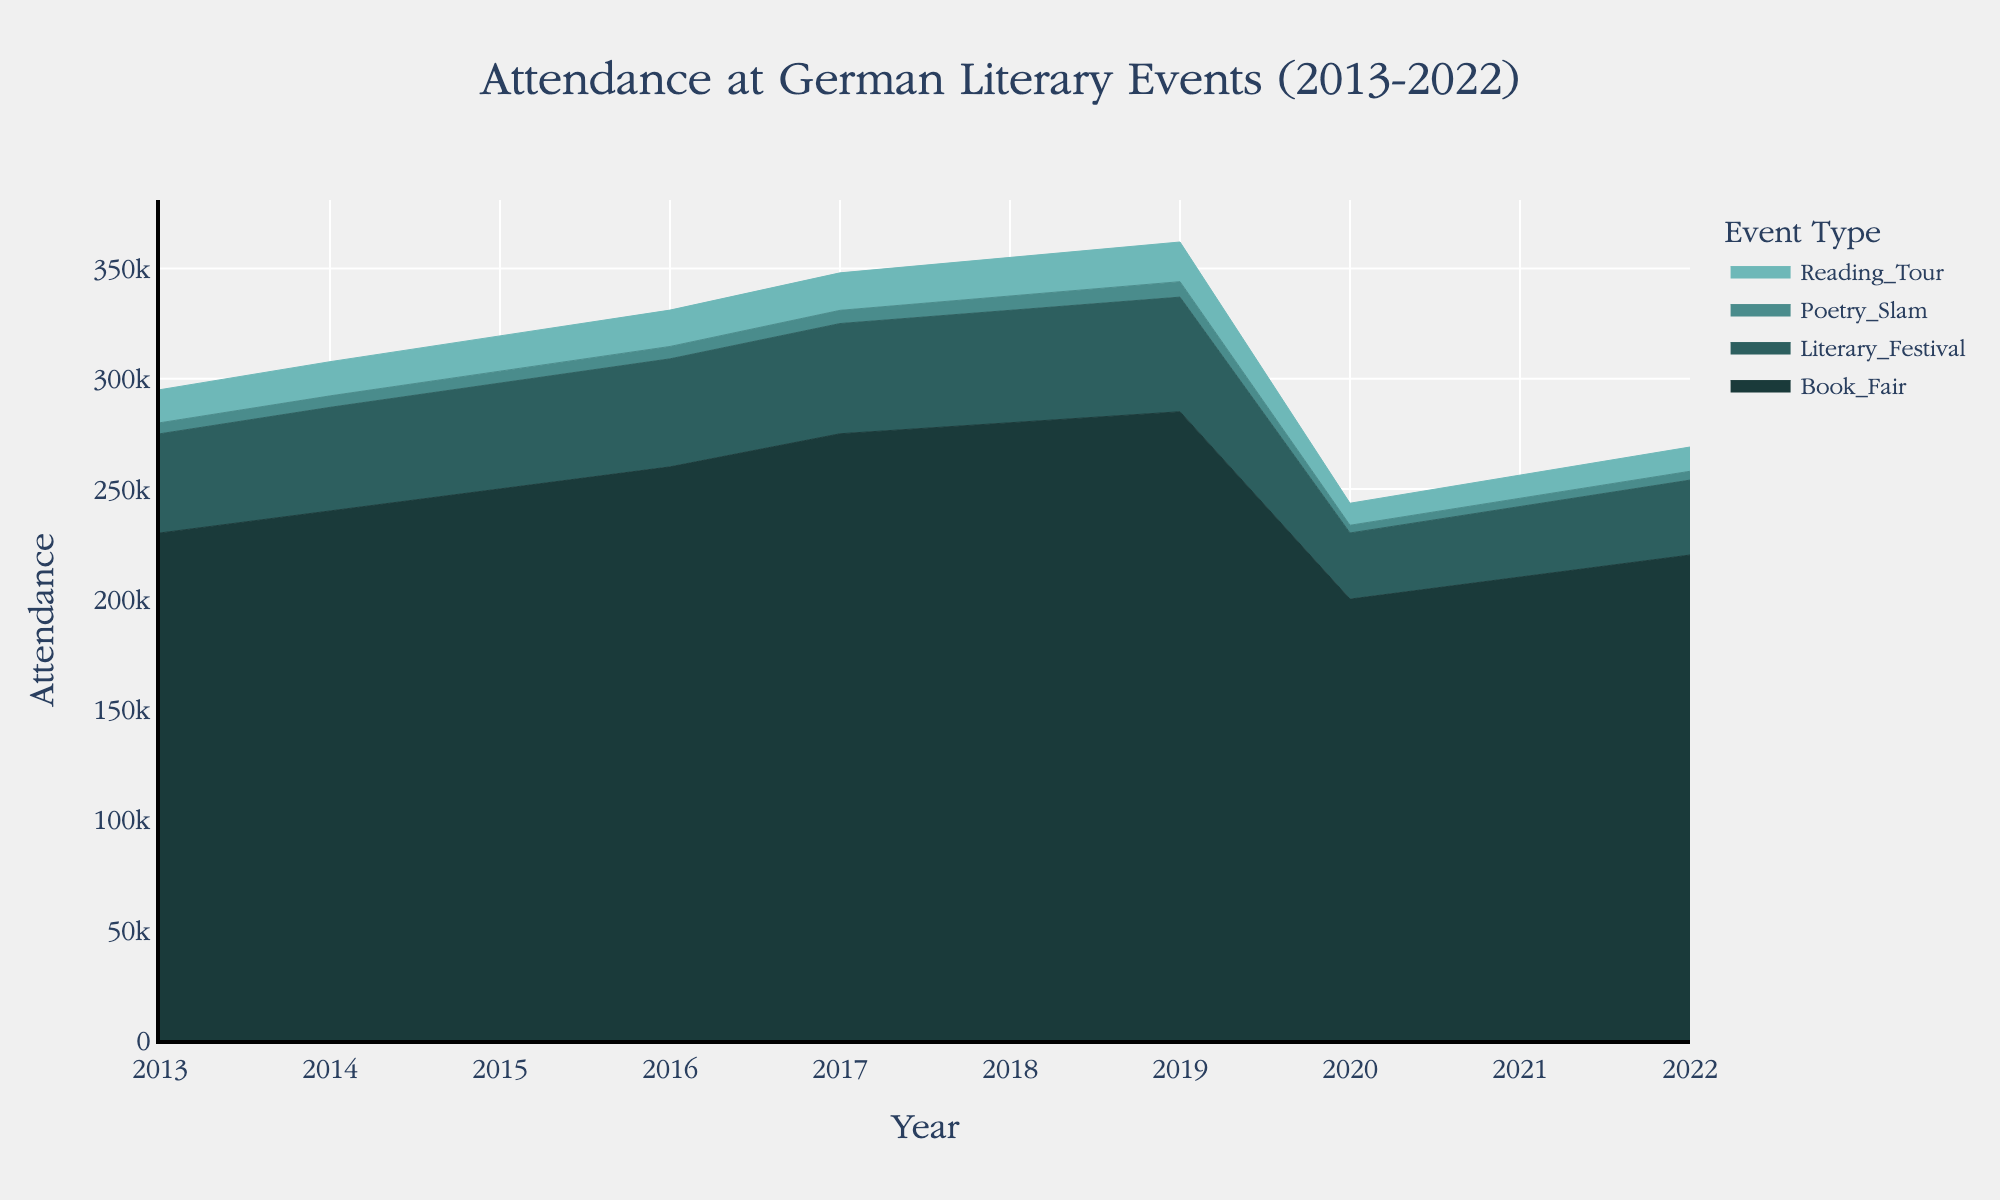What is the highest attendance recorded at the Frankfurt Book Fair between 2013 and 2022? Look at the segment of the stream graph corresponding to the Frankfurt Book Fair and identify the highest point in the time series. The peak value appears in 2019 with an attendance of 285,000.
Answer: 285,000 How did the attendance at the Berlin Literary Festival change from 2019 to 2020? Refer to the stream graph section for the Berlin Literary Festival and compare the attendance figures for the years 2019 (52,000) and 2020 (30,000). Calculate the difference: 52,000 - 30,000 = 22,000.
Answer: Decreased by 22,000 Which event type was most affected by the drop in attendance in 2020? Examine each stream's change from 2019 to 2020. The Frankfurt Book Fair shows the most significant drop, falling from 285,000 in 2019 to 200,000 in 2020, a decrease of 85,000.
Answer: Frankfurt Book Fair What is the overall trend in attendance at the Munich Reading Tour from 2013 to 2022? Observe the trend line for the Munich Reading Tour in the stream graph. The attendance gradually increases from 15,000 in 2013 to 18,000 in 2019, drops in 2020, and then starts to recover by 2022.
Answer: Increasing, with a drop in 2020 Compare the attendance trends of the Hamburg Poetry Slam and Berlin Literary Festival from 2013-2022. Compare the stream graph sections for both events. Both show upward trends until 2019, but the Poetry Slam experiences a smaller decline and quicker recovery post-2020 compared to the Literary Festival.
Answer: Similar upward trends; Poetry Slam had a smaller decline and quicker recovery During which year did the combined attendance of all events reach its lowest point between 2013 and 2022? Add the attendance values for each event type per year and identify the minimum total. The combined attendance is lowest in 2020 due to significant drops across all events.
Answer: 2020 What is the difference in attendance between the highest-attended and lowest-attended event in 2021? Refer to the stream graph data for 2021. The highest-attended event is the Frankfurt Book Fair (210,000), and the lowest-attended is the Hamburg Poetry Slam (3,700). Calculate the difference: 210,000 - 3,700 = 206,300.
Answer: 206,300 Which event type shows the fastest recovery in attendance post-2020? Analyze the gradient of the rise post-2020 for each event. The Frankfurt Book Fair shows a notable recovery with attendance rising from 200,000 in 2020 to 220,000 in 2022.
Answer: Frankfurt Book Fair What was the attendance at the Berlin Literary Festival in 2013? Refer to the stream graph and identify the starting value for the Berlin Literary Festival in 2013, which is 45,000.
Answer: 45,000 How much did the attendance at the Hamburg Poetry Slam change from 2013 to 2018? Find the attendance values for 2013 (5,000) and 2018 (6,500). Then, calculate the change: 6,500 - 5,000 = 1,500.
Answer: Increased by 1,500 